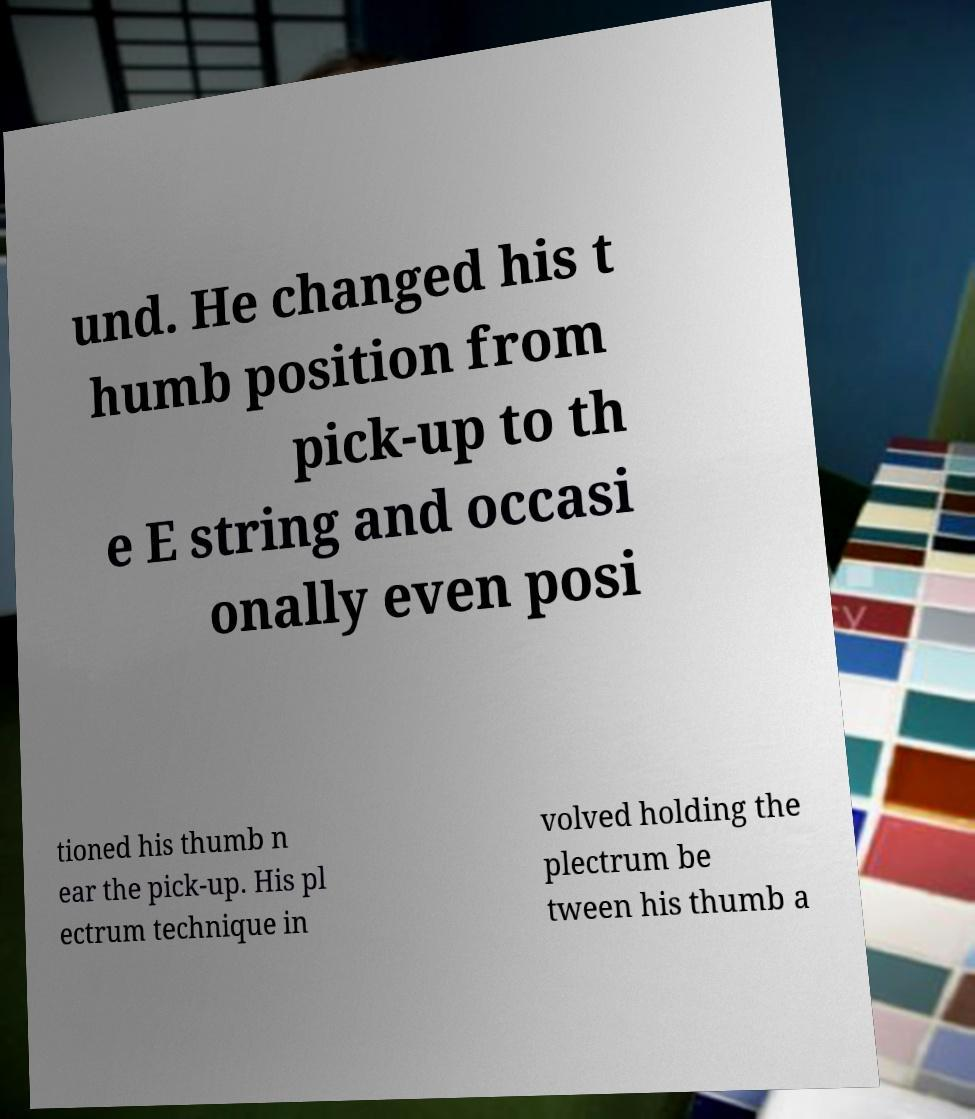Could you assist in decoding the text presented in this image and type it out clearly? und. He changed his t humb position from pick-up to th e E string and occasi onally even posi tioned his thumb n ear the pick-up. His pl ectrum technique in volved holding the plectrum be tween his thumb a 